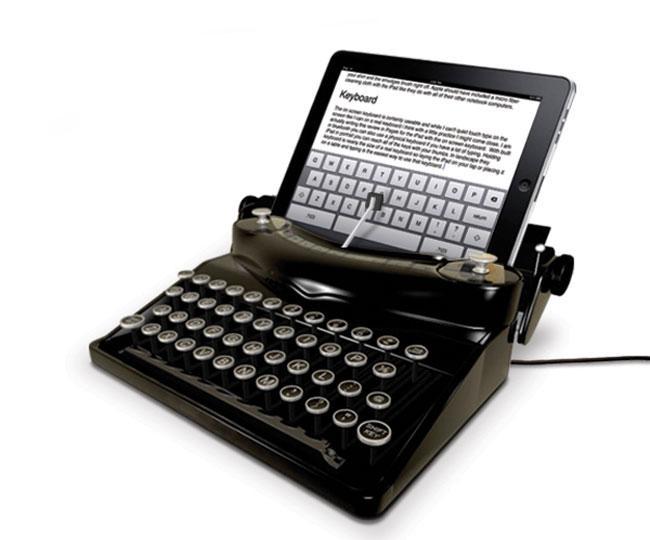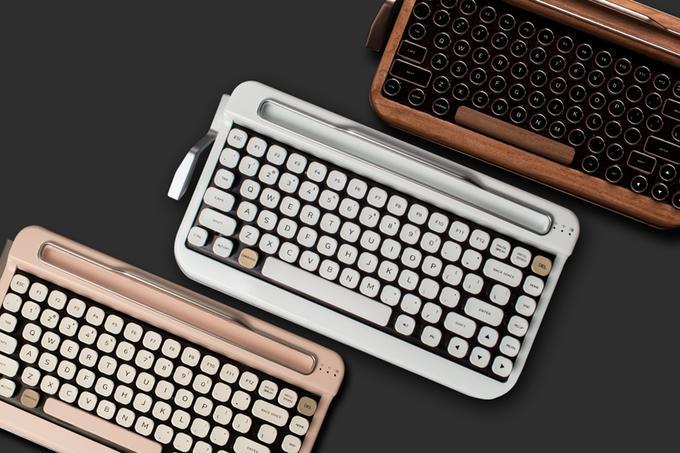The first image is the image on the left, the second image is the image on the right. Considering the images on both sides, is "One image includes a pair of human hands with one typewriter device." valid? Answer yes or no. No. The first image is the image on the left, the second image is the image on the right. For the images shown, is this caption "One photo includes a pair of human hands." true? Answer yes or no. No. 